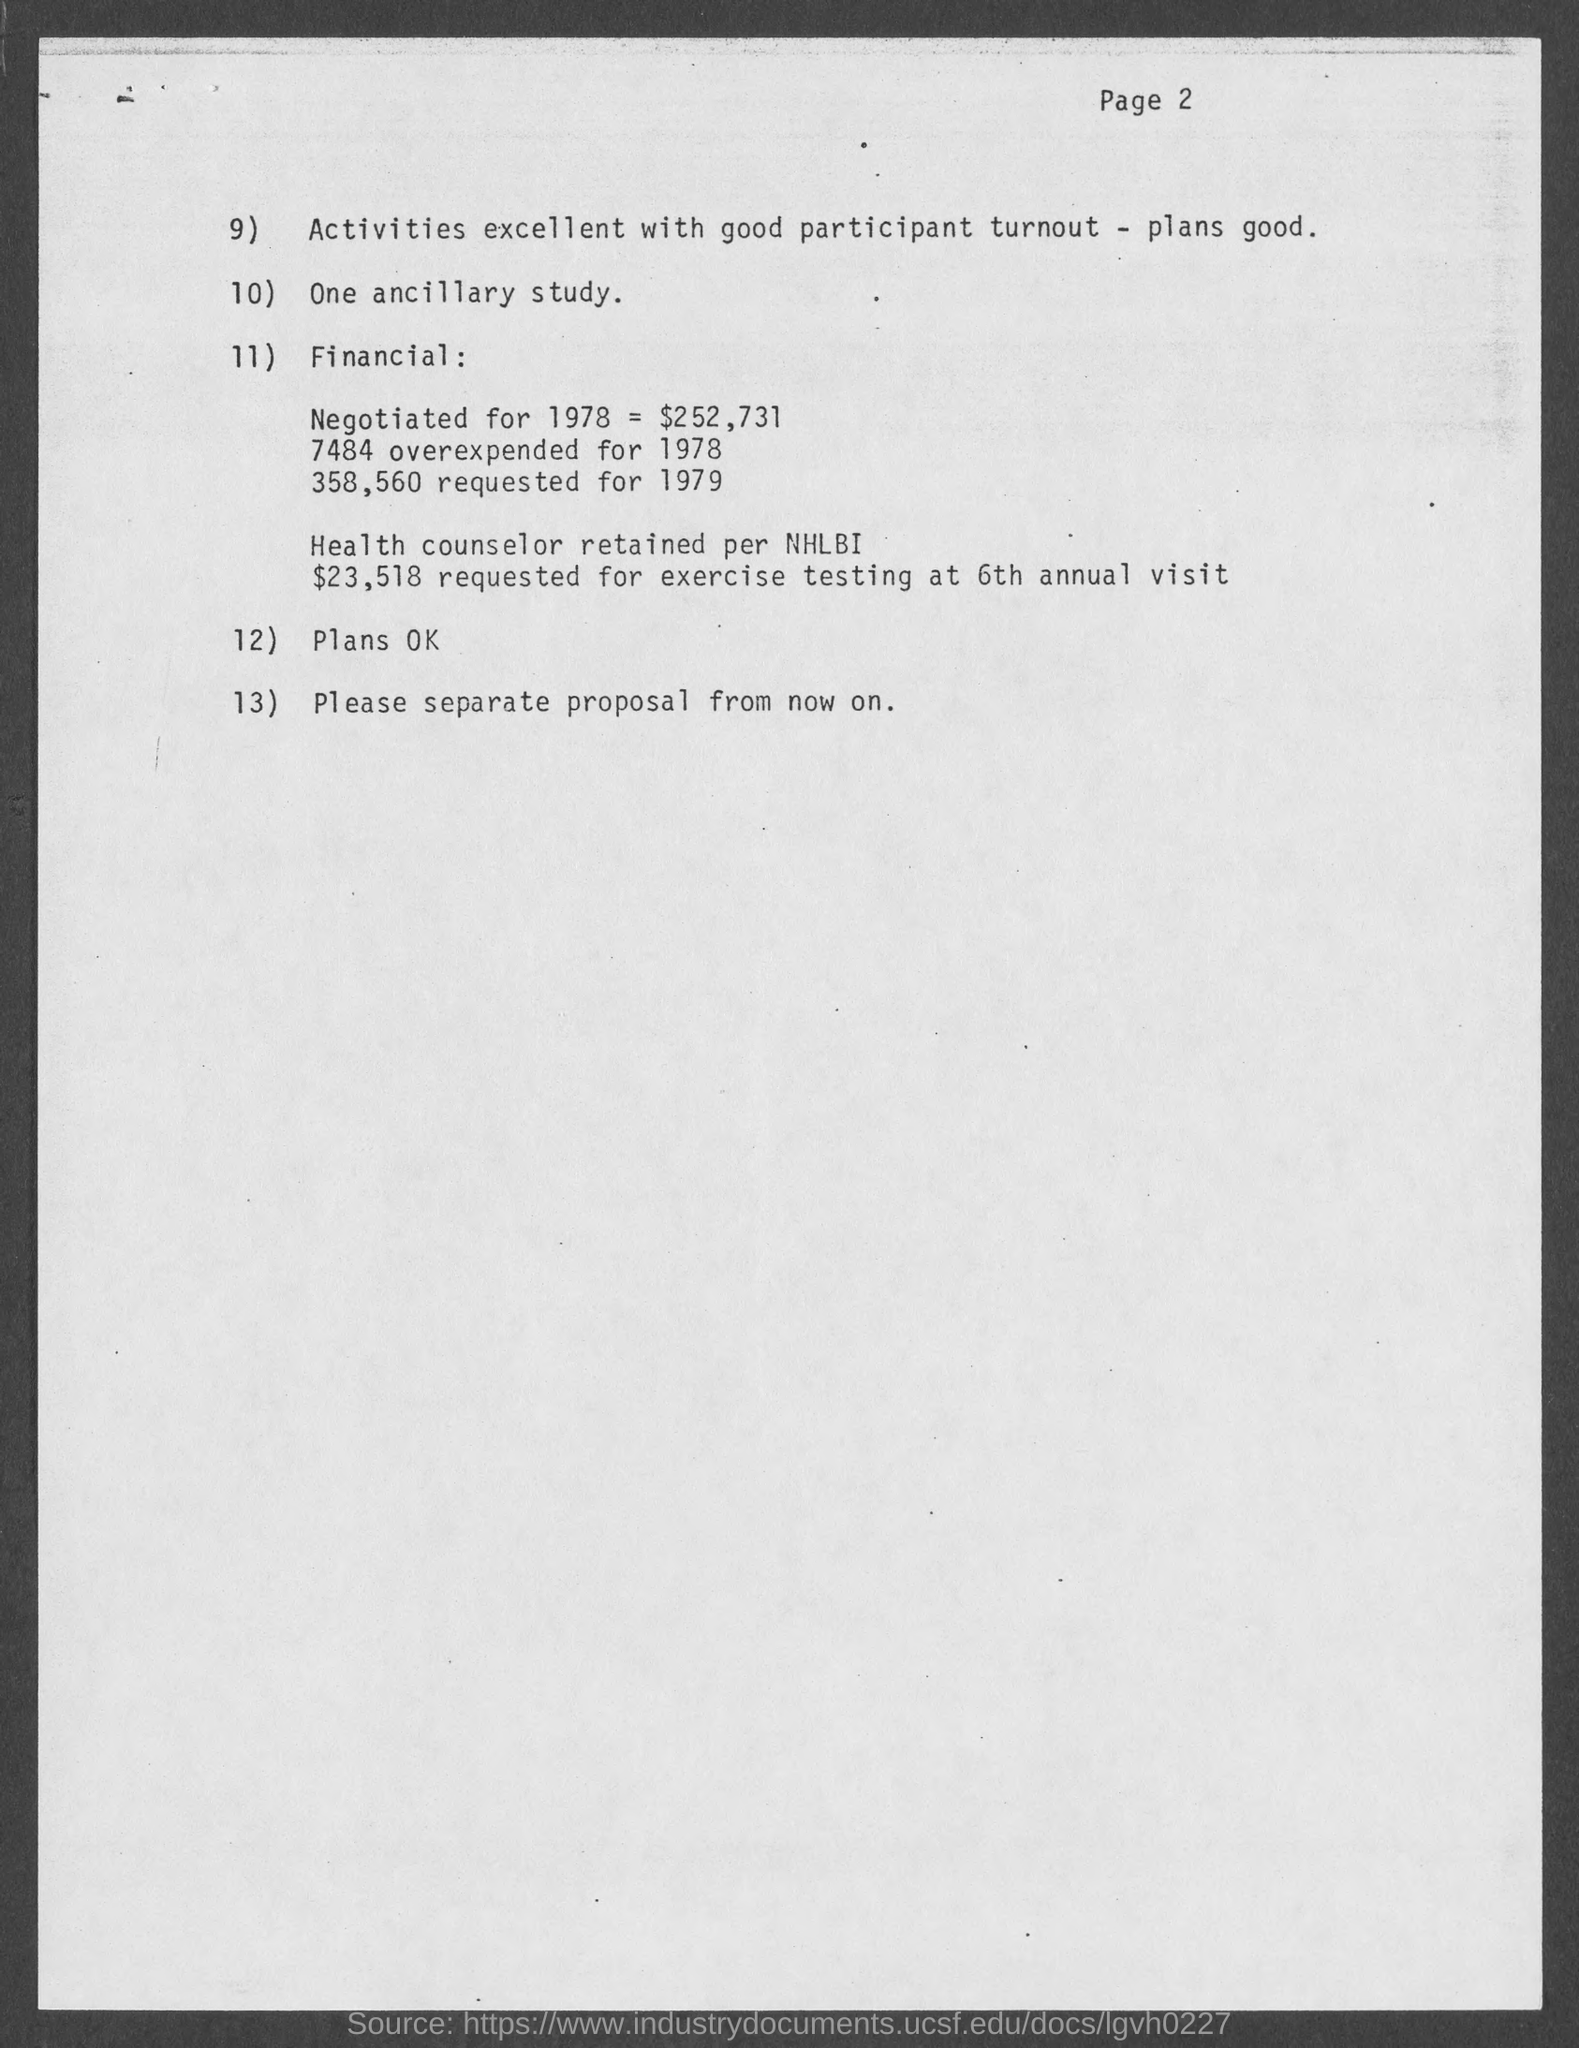Are there any financial details mentioned on this page? Yes, the document lists financial figures. For example, it mentions an amount negotiated for 1978 totaling $52,731, and an overexpenditure of 7484 for the same year. What activities does the document refer to? The document references 'activities' which are described as 'excellent with good participant turnout,' and it notes that there are plans laid out that are presumably related to these activities. 